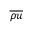<formula> <loc_0><loc_0><loc_500><loc_500>\overline { \rho } \overline { u }</formula> 